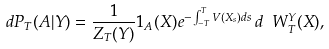<formula> <loc_0><loc_0><loc_500><loc_500>d P _ { T } ( A | Y ) = \frac { 1 } { Z _ { T } ( Y ) } 1 _ { A } ( X ) e ^ { - \int _ { - T } ^ { T } V ( X _ { s } ) d s } \, d \ W ^ { Y } _ { T } ( X ) ,</formula> 